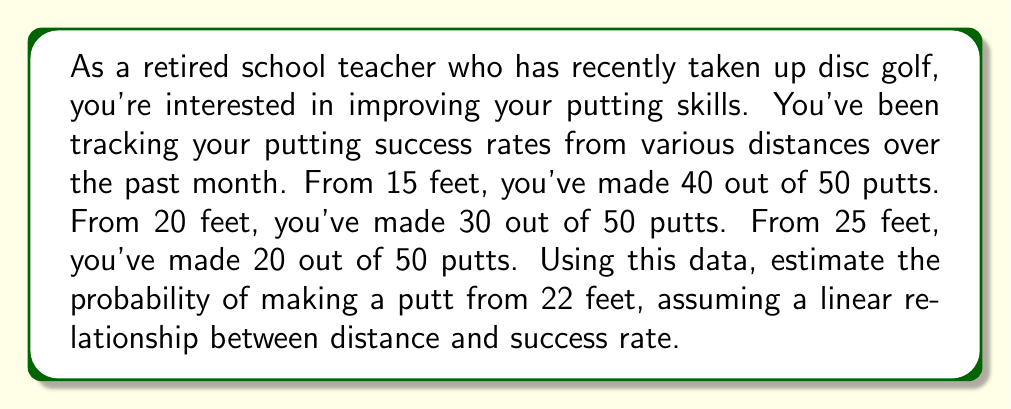Provide a solution to this math problem. To solve this problem, we'll use linear interpolation to estimate the probability of making a putt from 22 feet. Here's the step-by-step process:

1. Calculate the success rates for each distance:
   15 feet: $\frac{40}{50} = 0.8$ or 80%
   20 feet: $\frac{30}{50} = 0.6$ or 60%
   25 feet: $\frac{20}{50} = 0.4$ or 40%

2. We can see that there's a linear relationship between distance and success rate. Let's use the 20-foot and 25-foot data points to interpolate for 22 feet.

3. Calculate the slope of the line between these two points:
   $m = \frac{y_2 - y_1}{x_2 - x_1} = \frac{0.4 - 0.6}{25 - 20} = \frac{-0.2}{5} = -0.04$

4. Use the point-slope form of a line to find the equation:
   $y - y_1 = m(x - x_1)$
   $y - 0.6 = -0.04(x - 20)$

5. Solve for y to get the slope-intercept form:
   $y = -0.04x + 1.4$

6. Now, plug in x = 22 to find the estimated probability at 22 feet:
   $y = -0.04(22) + 1.4 = 0.52$

Therefore, the estimated probability of making a putt from 22 feet is 0.52 or 52%.
Answer: The estimated probability of making a putt from 22 feet is 0.52 or 52%. 